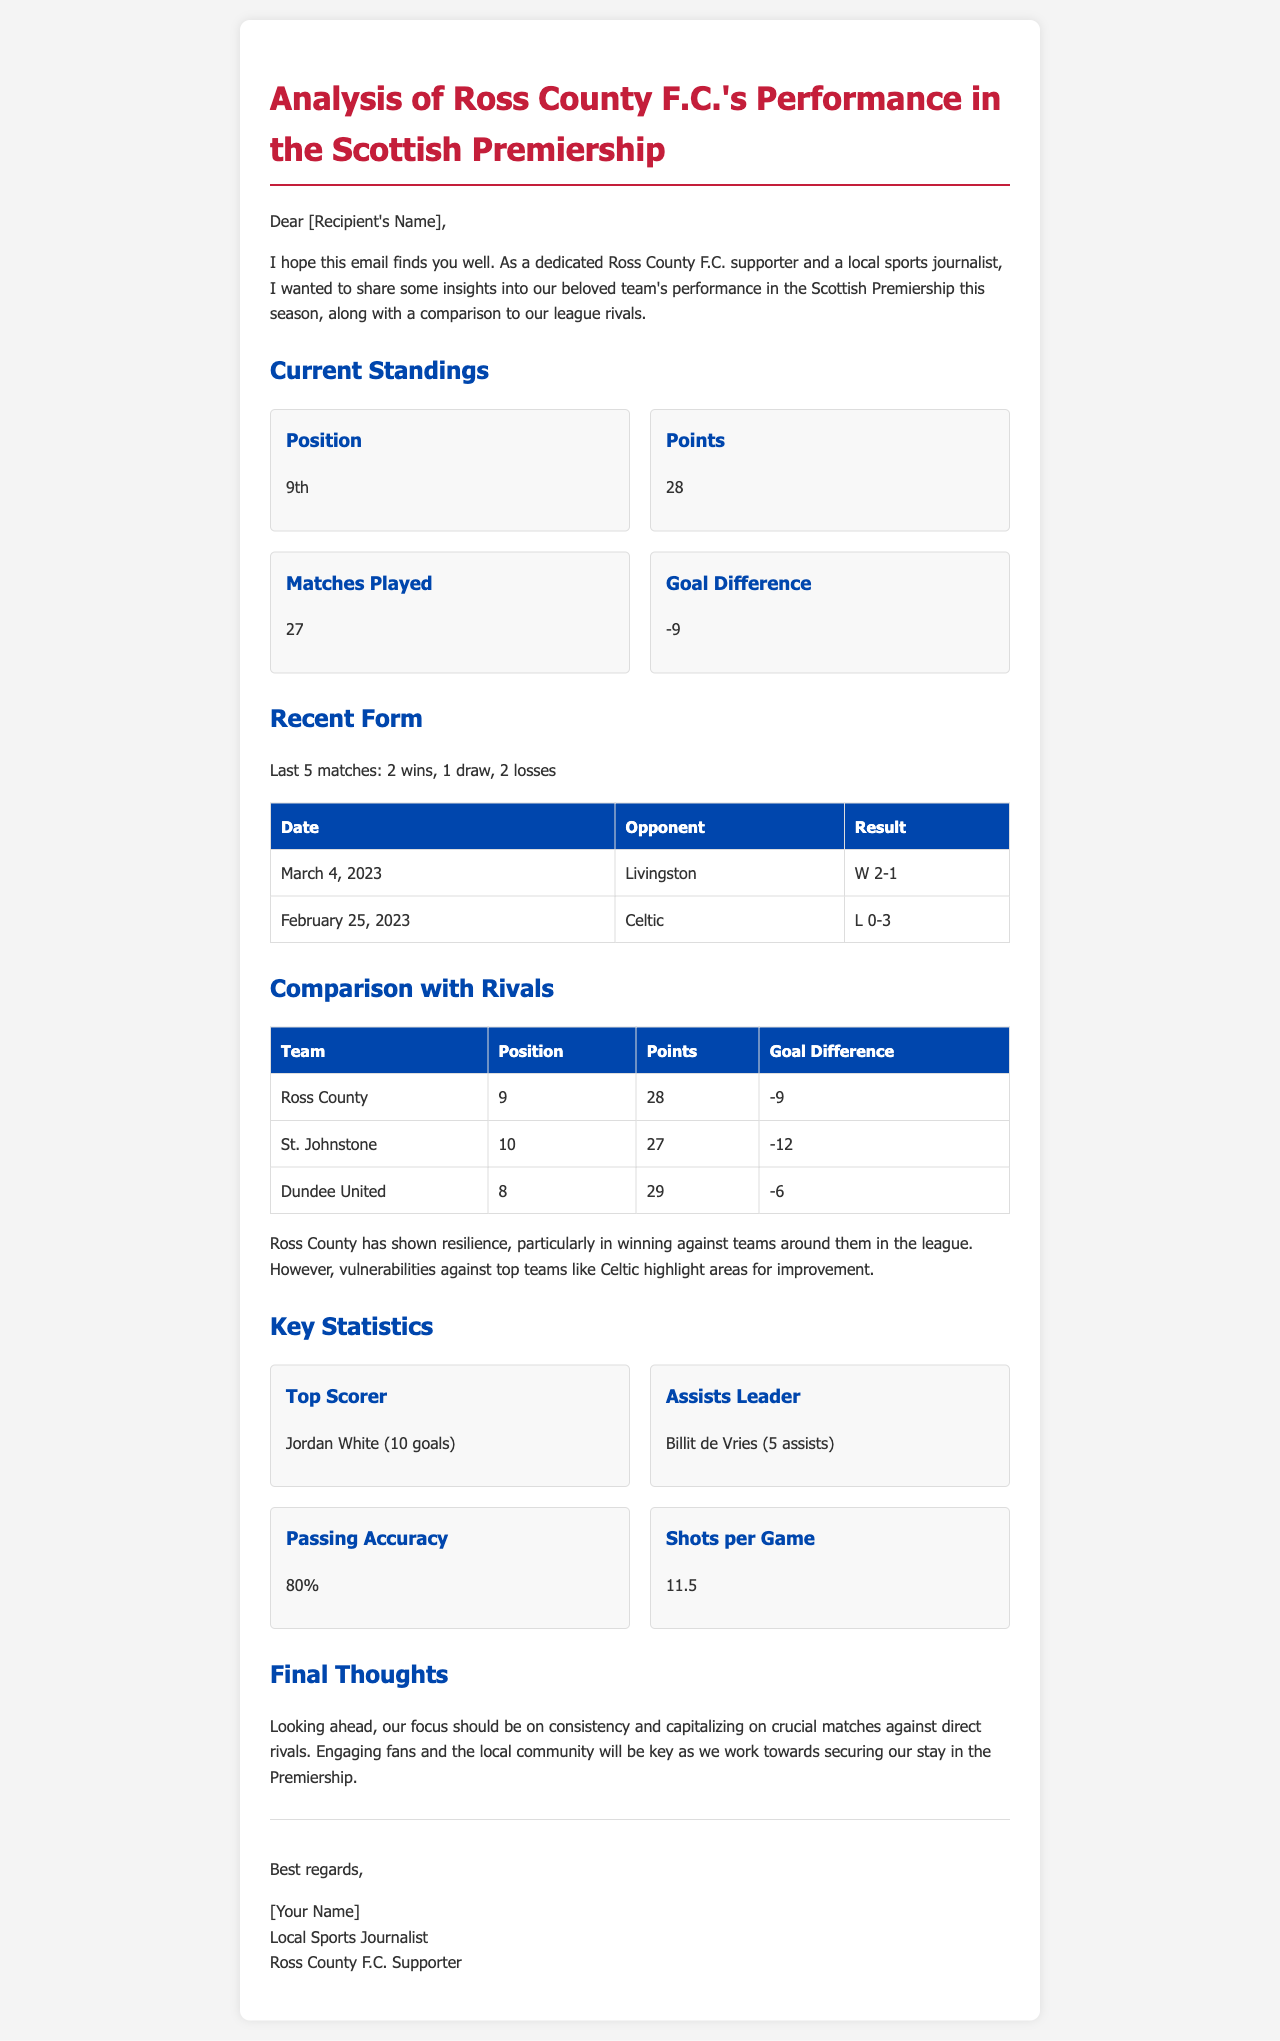What is Ross County's current position in the league? The current position of Ross County F.C. in the Scottish Premiership is stated as 9th.
Answer: 9th How many points does Ross County have? The document specifies that Ross County has accumulated 28 points in the league.
Answer: 28 What is the goal difference for Ross County? The goal difference is defined in the document, noted as -9 for Ross County.
Answer: -9 Who is the top scorer for Ross County? The top scorer is mentioned in the document as Jordan White, who has scored 10 goals.
Answer: Jordan White (10 goals) What was Ross County's result against Celtic? The document outlines the match result against Celtic as a loss with a score of 0-3.
Answer: L 0-3 Which team is positioned directly below Ross County? St. Johnstone is identified in the table as the team right below Ross County in the standings.
Answer: St. Johnstone What is the assists leader's name for Ross County? The name of the assists leader for Ross County is provided as Billit de Vries with 5 assists.
Answer: Billit de Vries (5 assists) What strategy is recommended for Ross County moving forward? The document suggests focusing on consistency and capitalizing on crucial matches against direct rivals.
Answer: Consistency and crucial matches What was Ross County's last match result? The last match result listed in the document is a win against Livingston, with a score of 2-1.
Answer: W 2-1 